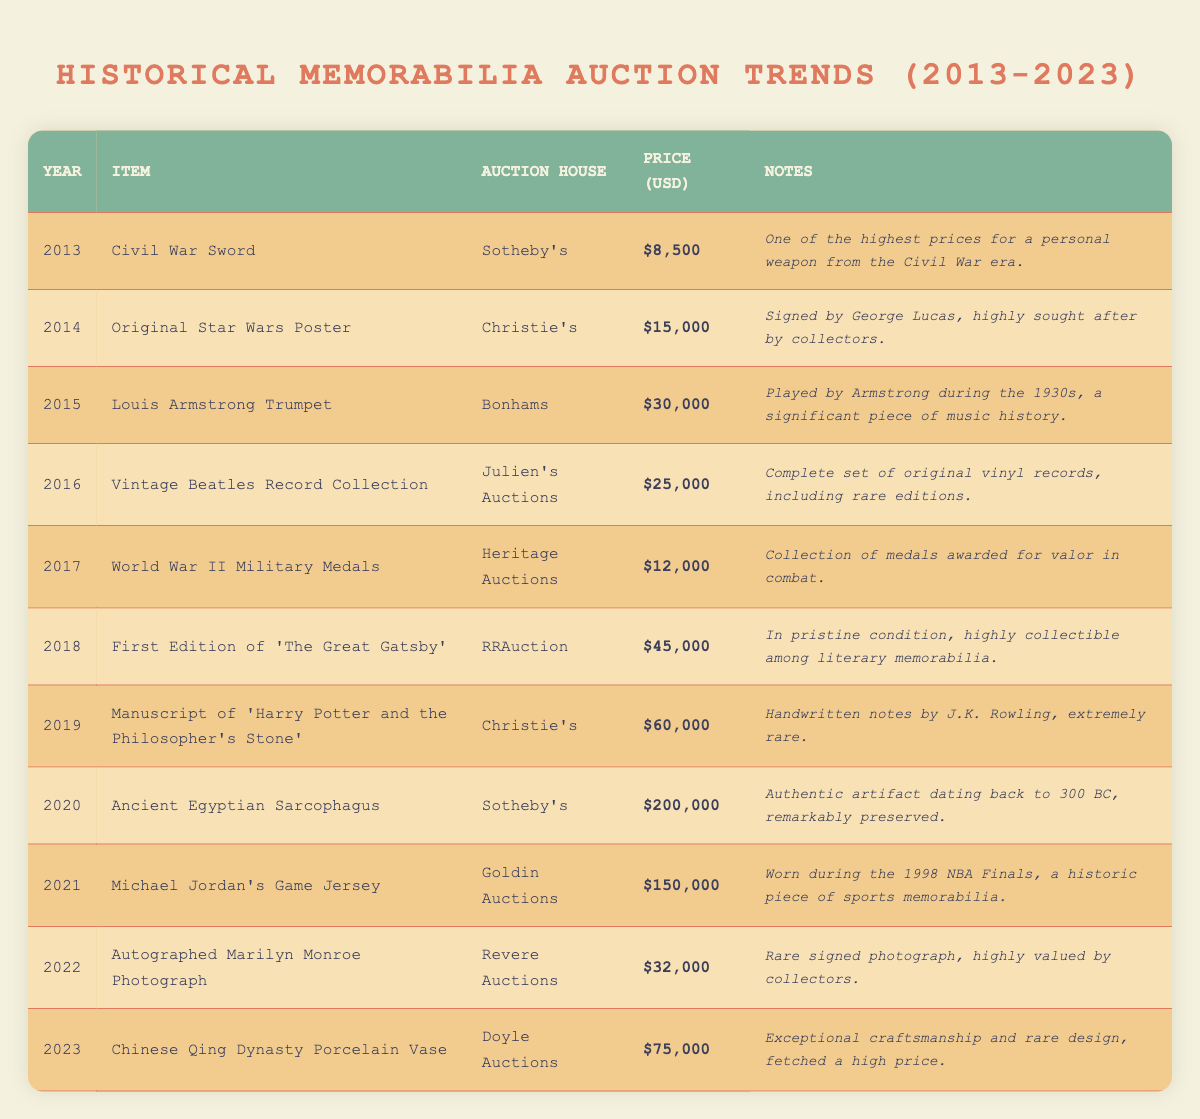What was the highest auction price recorded from 2013 to 2023? The highest auction price is found in the year 2020 for the Ancient Egyptian Sarcophagus, which sold for $200,000.
Answer: $200,000 How many years had auction prices over $50,000? The years 2019 and 2020 had auction prices over $50,000, totaling two years.
Answer: 2 years What is the average auction price for the items listed from 2013 to 2023? To calculate the average, we sum all the auction prices: 8500 + 15000 + 30000 + 25000 + 12000 + 45000 + 60000 + 200000 + 150000 + 32000 + 75000 =  411500. There are 11 items, so the average is 411500 / 11 = 37409.09, rounded to 37409.
Answer: 37,409 Did any items auctioned in 2021 sell for less than $100,000? Yes, in 2021, Michael Jordan's Game Jersey sold for $150,000, which is above $100,000. Therefore, there are no items in that year under $100,000.
Answer: No Which auction house sold the most expensive item and what was that item? Sotheby's sold the most expensive item, the Ancient Egyptian Sarcophagus, for $200,000 in 2020.
Answer: Sotheby's, Ancient Egyptian Sarcophagus In which year did the auction price increase the most compared to the previous year? To find the year with the highest increase, we can compare the differences between years: 2014 to 2013 is $6,500, 2015 to 2014 is $15,000, 2016 to 2015 is -$5,000, 2017 to 2016 is -$13,000, 2018 to 2017 is $33,000, 2019 to 2018 is $15,000, 2020 to 2019 is $140,000, 2021 to 2020 is -$50,000, 2022 to 2021 is -$118,000, and 2023 to 2022 is $43,000. The largest increase is from 2019 to 2020, with the price rising by $140,000.
Answer: 2020 Was there any memorabilia related to WWII sold at auction in these years? Yes, the World War II Military Medals were sold in 2017.
Answer: Yes What was the price difference between the item with the lowest price and the highest price? The lowest price in the dataset is $8,500 for the Civil War Sword in 2013, and the highest is $200,000 for the Ancient Egyptian Sarcophagus in 2020. The difference is $200,000 - $8,500 = $191,500.
Answer: $191,500 